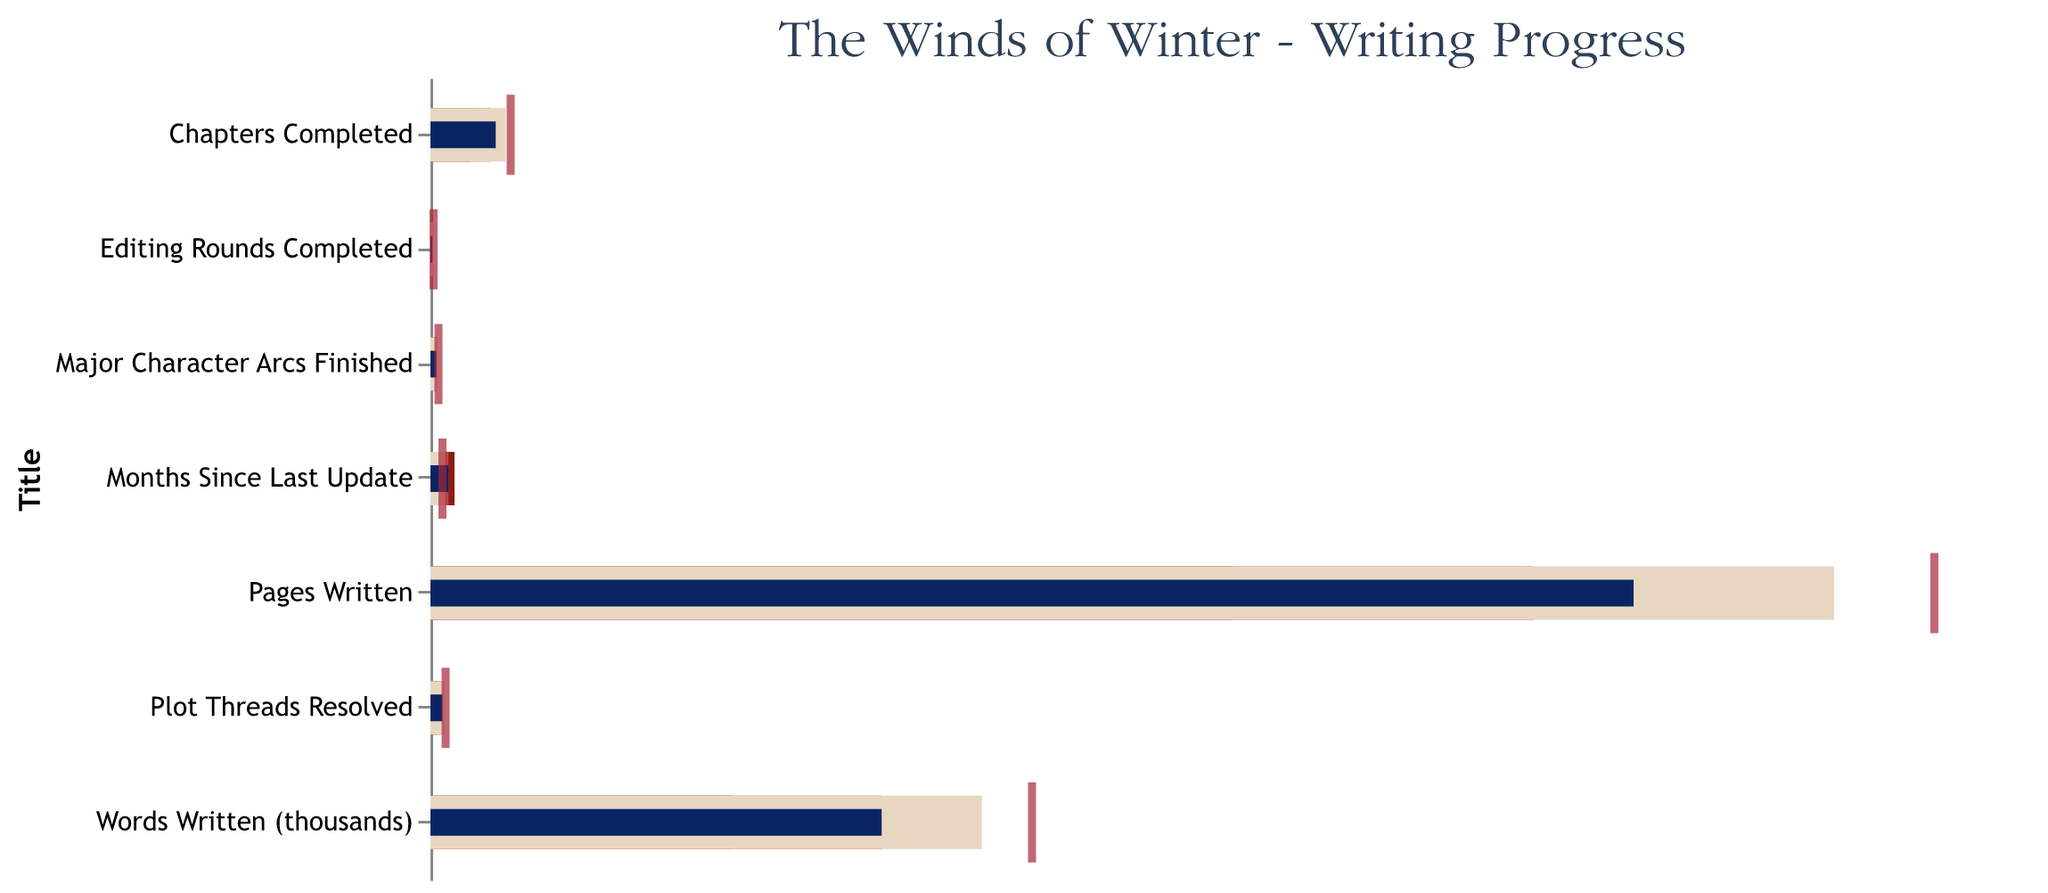What is the title of the chart? The title of the chart is displayed at the top and is "The Winds of Winter - Writing Progress".
Answer: The Winds of Winter - Writing Progress What is the actual number of chapters completed versus the target? The "Chapters Completed" category shows 65 (blue bar) for the actual and 80 (red tick) for the target.
Answer: 65 vs 80 How many months since the last update? The "Months Since Last Update" category shows 18 months in the blue bar.
Answer: 18 Which category has the highest actual value relative to its target? By comparing the actual values (blue bars) and targets (red ticks), the "Words Written (thousands)" category has the highest actual value relative to its target (450 versus 600).
Answer: Words Written (thousands) Which metric meets the 'good' threshold? The "Words Written (thousands)" and "Plot Threads Resolved" categories both fall into the 'Good' range (last segment of their bars).
Answer: Words Written (thousands) and Plot Threads Resolved Which metric is furthest behind its target? "Months Since Last Update" has an actual value (18) that is higher than the target (12), indicating it is furthest behind the desired goal.
Answer: Months Since Last Update What are the poor, satisfactory, and good thresholds for "Pages Written?" The "Pages Written" category has poor, satisfactory, and good thresholds of 800, 1100, and 1400 pages respectively.
Answer: 800, 1100, 1400 How many major character arcs have been finished? The "Major Character Arcs Finished" category shows 6 arcs in the blue bar.
Answer: 6 Which category has the smallest difference between actual and target values? By comparing the differences, "Editing Rounds Completed" has the smallest difference, with the actual being 2 and the target 3.
Answer: Editing Rounds Completed 